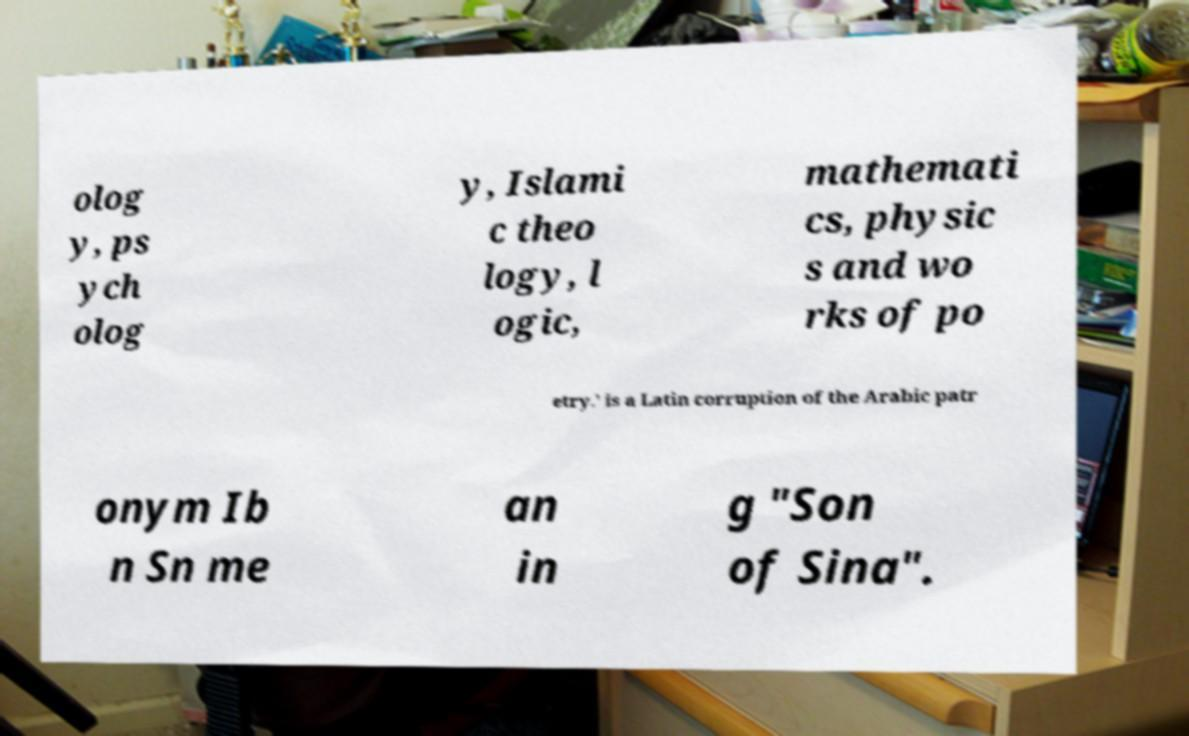Please read and relay the text visible in this image. What does it say? olog y, ps ych olog y, Islami c theo logy, l ogic, mathemati cs, physic s and wo rks of po etry.' is a Latin corruption of the Arabic patr onym Ib n Sn me an in g "Son of Sina". 